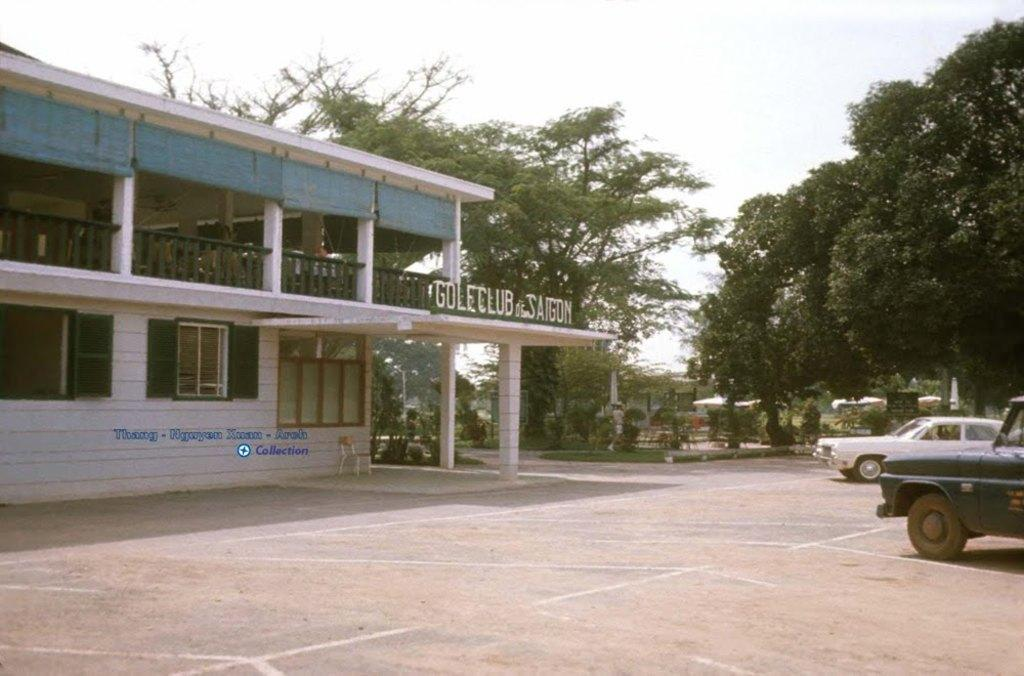What structure is located on the left side of the image? There is a building on the left side of the image. What can be seen in the parking lot on the right side of the image? There are two cars parked in the parking lot on the right side of the image. What type of vegetation is in the background of the image? There are trees in the background of the image. What is visible in the background of the image besides the trees? The sky is visible in the background of the image. Where is the care located in the image? There is no care present in the image. Is there an attack happening in the image? No, there is no attack depicted in the image. 